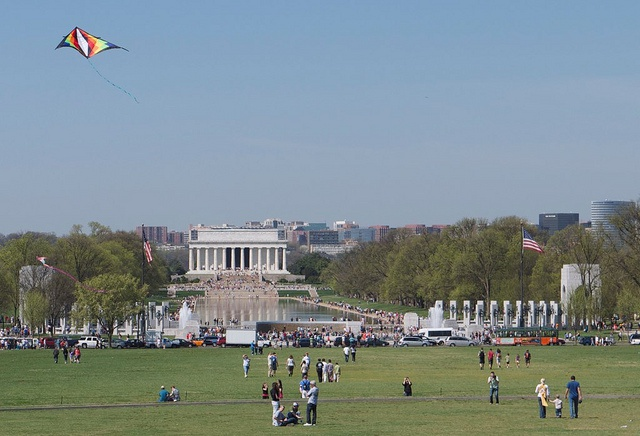Describe the objects in this image and their specific colors. I can see people in darkgray, gray, and black tones, car in darkgray, gray, black, and lightgray tones, bus in darkgray, gray, black, and brown tones, kite in darkgray, lavender, lightblue, and gray tones, and truck in darkgray, lightgray, black, and gray tones in this image. 